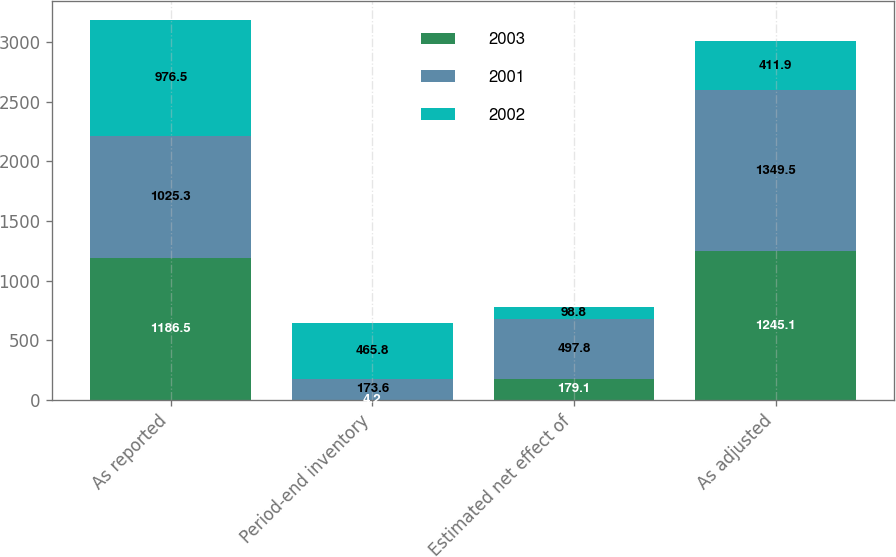<chart> <loc_0><loc_0><loc_500><loc_500><stacked_bar_chart><ecel><fcel>As reported<fcel>Period-end inventory<fcel>Estimated net effect of<fcel>As adjusted<nl><fcel>2003<fcel>1186.5<fcel>4.2<fcel>179.1<fcel>1245.1<nl><fcel>2001<fcel>1025.3<fcel>173.6<fcel>497.8<fcel>1349.5<nl><fcel>2002<fcel>976.5<fcel>465.8<fcel>98.8<fcel>411.9<nl></chart> 